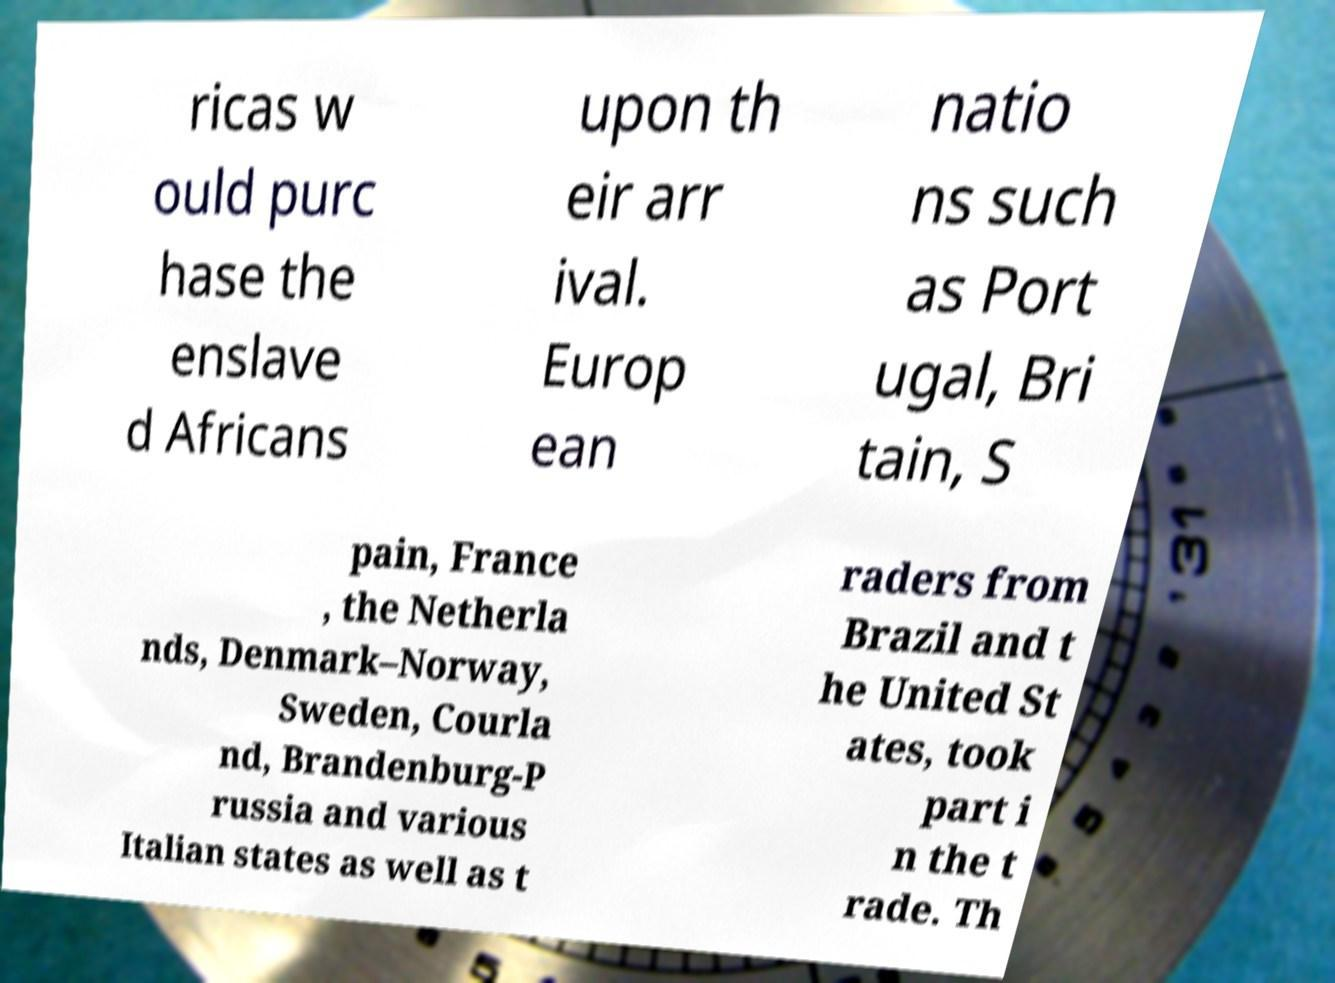Can you accurately transcribe the text from the provided image for me? ricas w ould purc hase the enslave d Africans upon th eir arr ival. Europ ean natio ns such as Port ugal, Bri tain, S pain, France , the Netherla nds, Denmark–Norway, Sweden, Courla nd, Brandenburg-P russia and various Italian states as well as t raders from Brazil and t he United St ates, took part i n the t rade. Th 